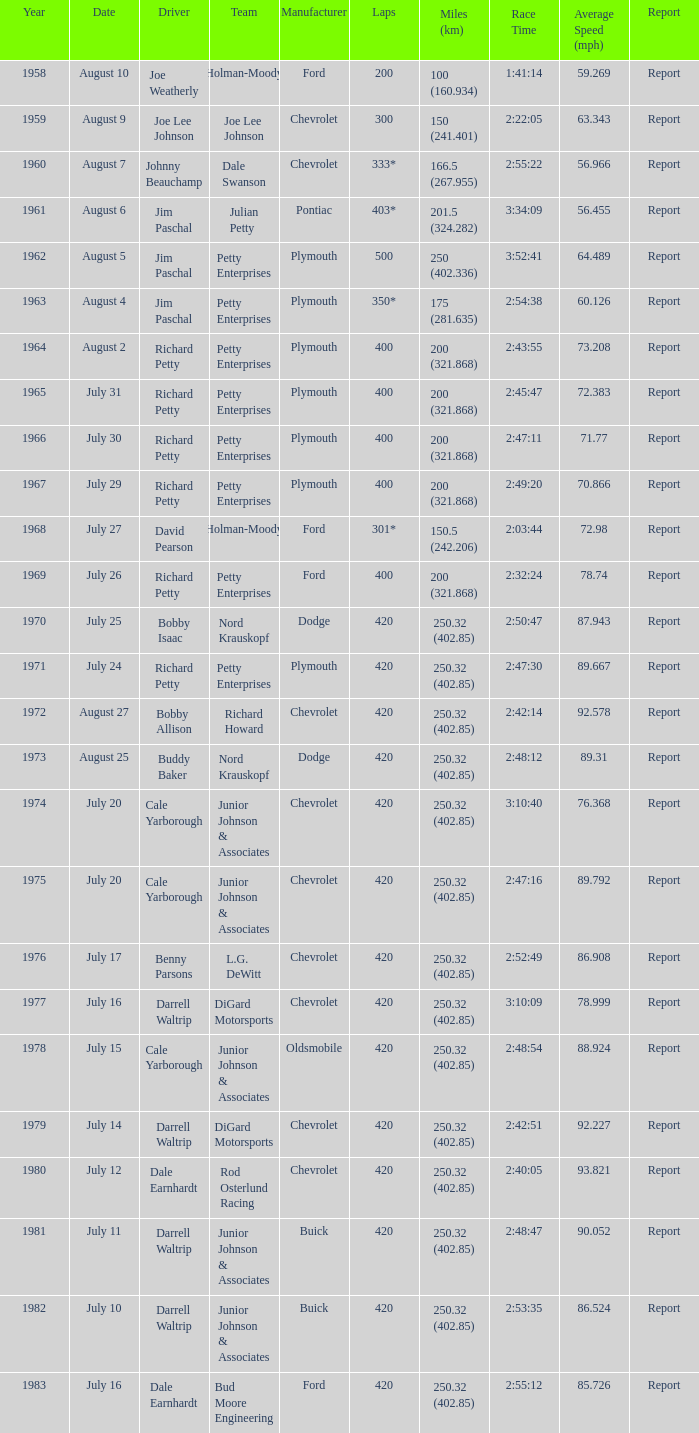In a race with a winning time of 2 hours, 47 minutes, and 11 seconds, what was the number of miles raced? 200 (321.868). 